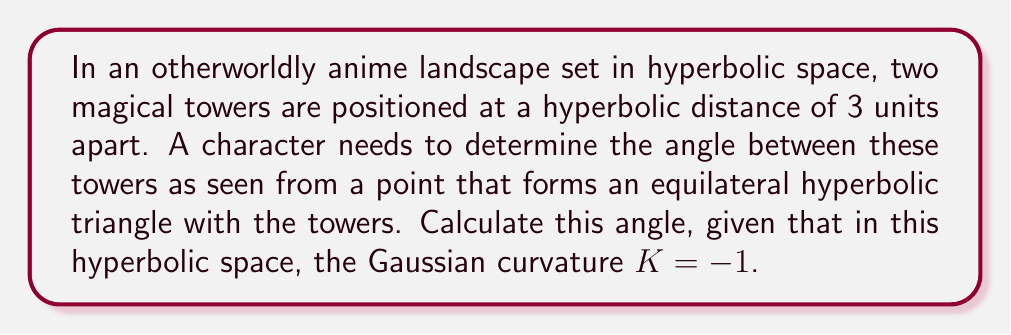Show me your answer to this math problem. To solve this problem, we'll use the hyperbolic law of cosines and the properties of equilateral triangles in hyperbolic space.

Step 1: Recall the hyperbolic law of cosines for a triangle with sides a, b, c and angles A, B, C opposite to these sides respectively:

$$\cosh c = \cosh a \cosh b - \sinh a \sinh b \cos C$$

Step 2: In our equilateral hyperbolic triangle, all sides are equal to 3 units, and all angles are equal. Let's call this angle θ. So, a = b = c = 3, and A = B = C = θ.

Step 3: Substitute these values into the hyperbolic law of cosines:

$$\cosh 3 = \cosh 3 \cosh 3 - \sinh 3 \sinh 3 \cos θ$$

Step 4: Simplify using hyperbolic function identities:

$$\cosh 3 = \cosh^2 3 - \sinh^2 3 \cos θ$$

Step 5: Use the identity $\sinh^2 x = \cosh^2 x - 1$ to rewrite $\sinh^2 3$:

$$\cosh 3 = \cosh^2 3 - (\cosh^2 3 - 1) \cos θ$$

Step 6: Simplify:

$$\cosh 3 = \cosh^2 3 - \cosh^2 3 \cos θ + \cos θ$$

Step 7: Rearrange to isolate $\cos θ$:

$$\cos θ (\cosh^2 3 - 1) = \cosh^2 3 - \cosh 3$$

Step 8: Solve for $\cos θ$:

$$\cos θ = \frac{\cosh^2 3 - \cosh 3}{\cosh^2 3 - 1}$$

Step 9: Calculate the numerical values (you can use a calculator for this):

$$\cos θ = \frac{(10.0676)^2 - 10.0676}{(10.0676)^2 - 1} \approx 0.9004$$

Step 10: To find θ, take the inverse cosine (arccos) of this value:

$$θ = \arccos(0.9004) \approx 0.4506 \text{ radians}$$

Step 11: Convert to degrees:

$$θ \approx 0.4506 \times \frac{180°}{\pi} \approx 25.82°$$
Answer: $25.82°$ 